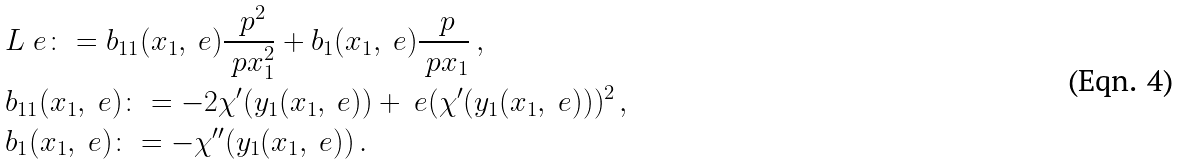<formula> <loc_0><loc_0><loc_500><loc_500>& L _ { \ } e \colon = b _ { 1 1 } ( x _ { 1 } , \ e ) \frac { \ p ^ { 2 } } { \ p x _ { 1 } ^ { 2 } } + b _ { 1 } ( x _ { 1 } , \ e ) \frac { \ p } { \ p x _ { 1 } } \, , \\ & b _ { 1 1 } ( x _ { 1 } , \ e ) \colon = - 2 \chi ^ { \prime } ( y _ { 1 } ( x _ { 1 } , \ e ) ) + \ e ( \chi ^ { \prime } ( y _ { 1 } ( x _ { 1 } , \ e ) ) ) ^ { 2 } \, , \\ & b _ { 1 } ( x _ { 1 } , \ e ) \colon = - \chi ^ { \prime \prime } ( y _ { 1 } ( x _ { 1 } , \ e ) ) \, .</formula> 